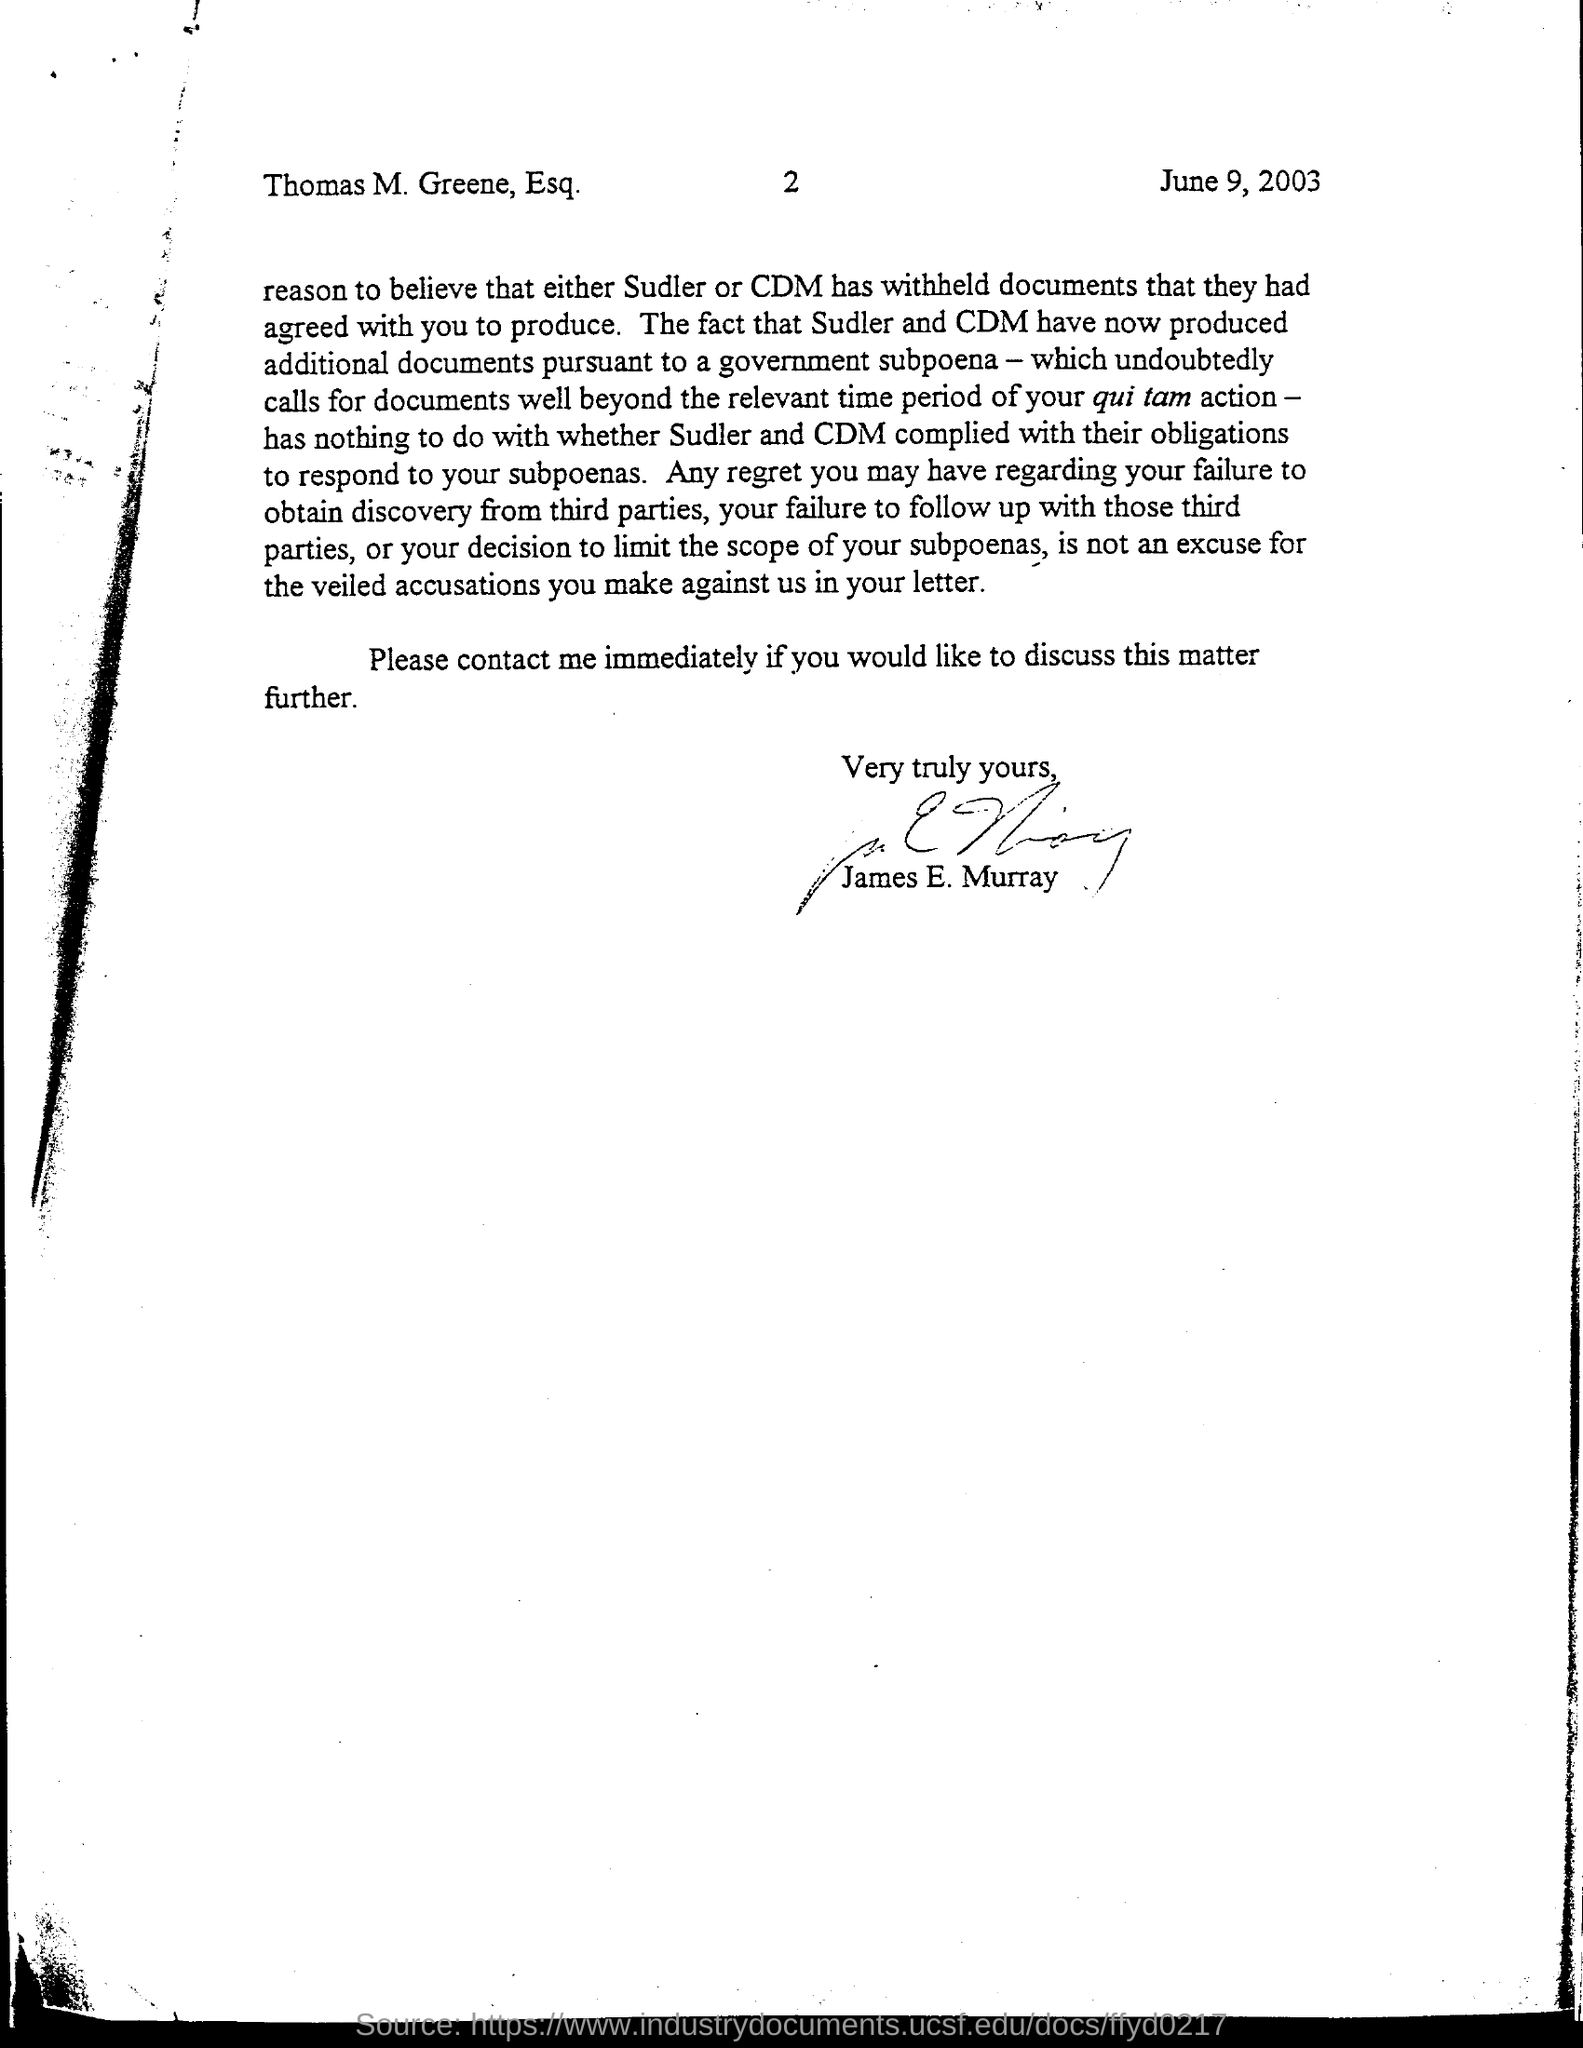What is the date mentioned in this document?
Make the answer very short. June 9, 2003. What is the page no mentioned in this document?
Provide a succinct answer. 2. Who has signed this document?
Make the answer very short. James E. Murray. 